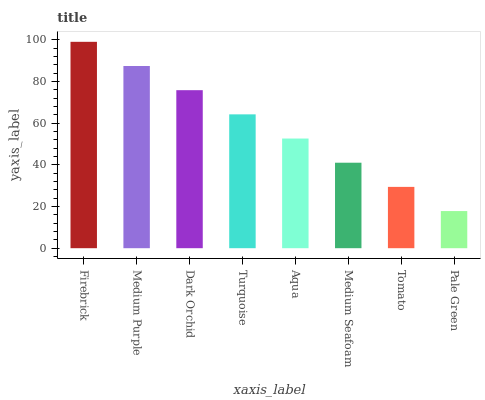Is Medium Purple the minimum?
Answer yes or no. No. Is Medium Purple the maximum?
Answer yes or no. No. Is Firebrick greater than Medium Purple?
Answer yes or no. Yes. Is Medium Purple less than Firebrick?
Answer yes or no. Yes. Is Medium Purple greater than Firebrick?
Answer yes or no. No. Is Firebrick less than Medium Purple?
Answer yes or no. No. Is Turquoise the high median?
Answer yes or no. Yes. Is Aqua the low median?
Answer yes or no. Yes. Is Pale Green the high median?
Answer yes or no. No. Is Turquoise the low median?
Answer yes or no. No. 